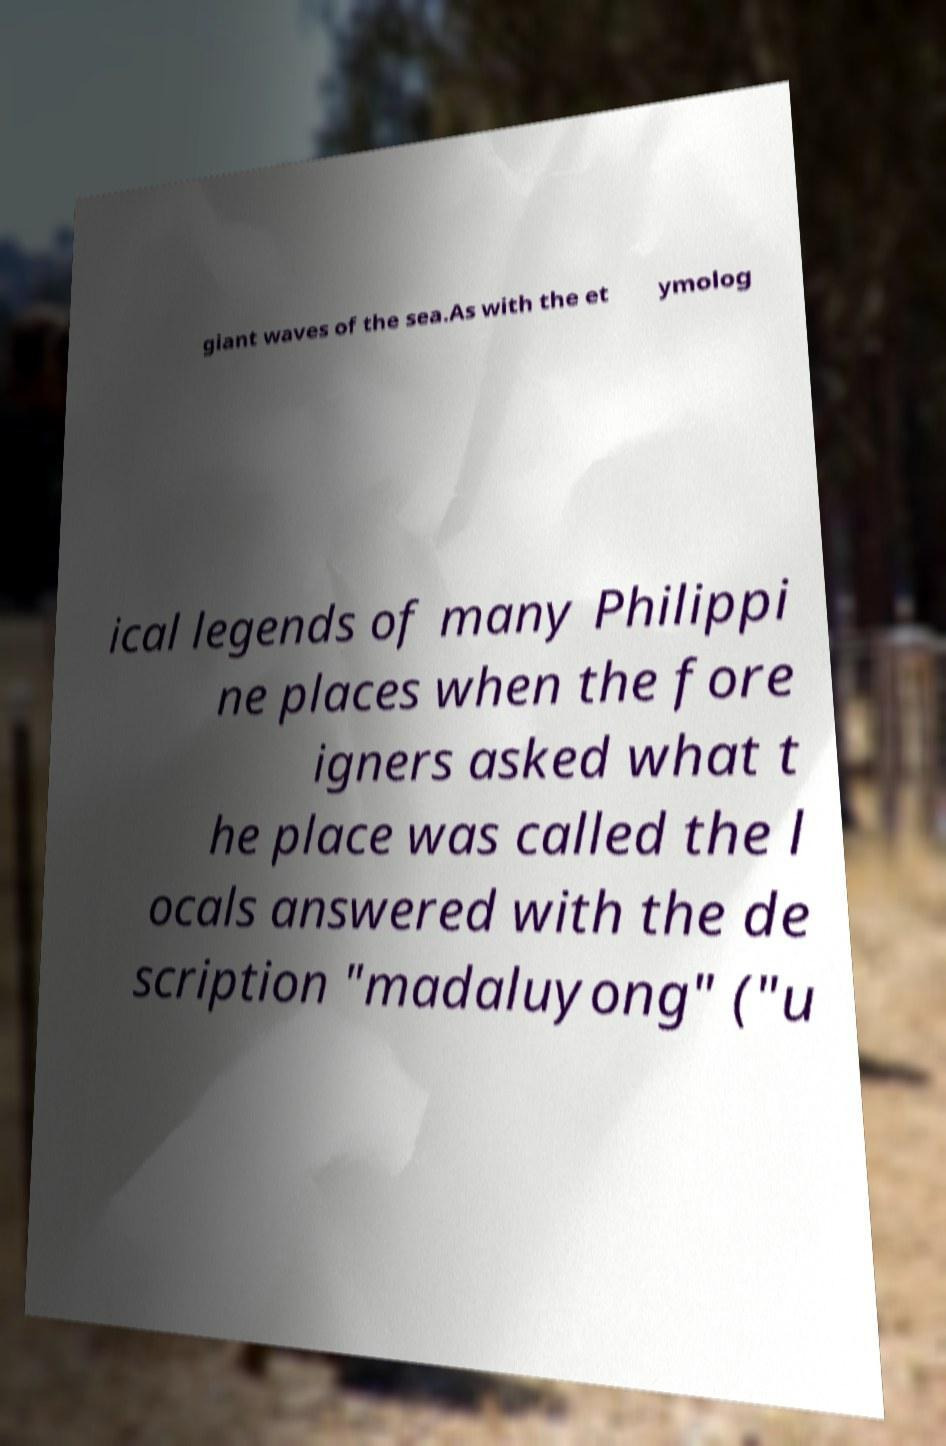Please identify and transcribe the text found in this image. giant waves of the sea.As with the et ymolog ical legends of many Philippi ne places when the fore igners asked what t he place was called the l ocals answered with the de scription "madaluyong" ("u 